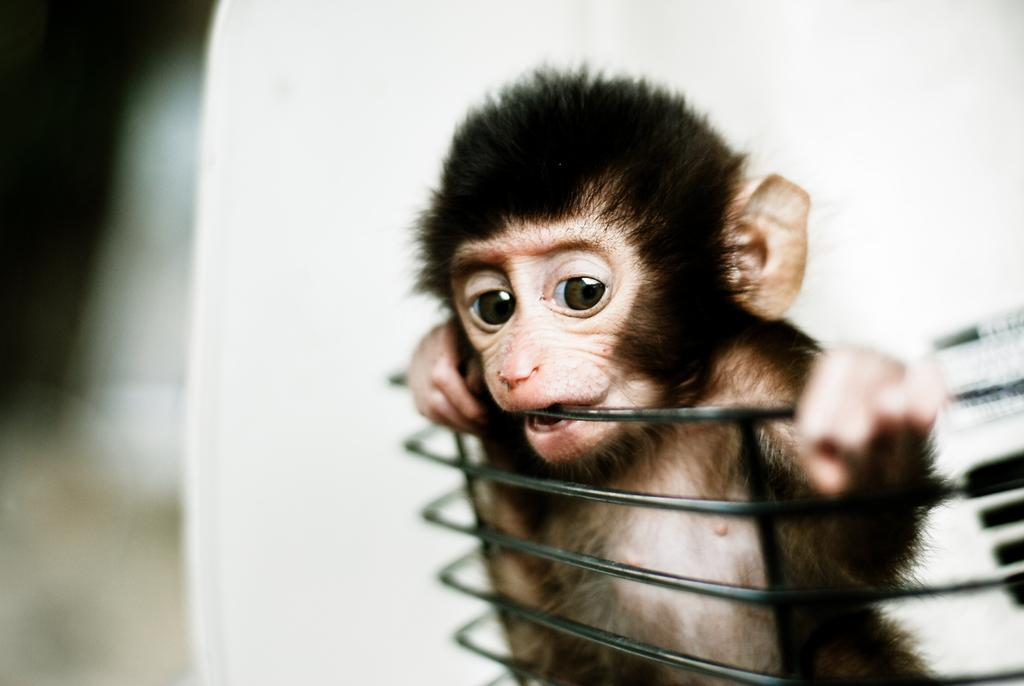What is the main subject of the image? There is a black color monkey in the image. What color is the background of the image? The background of the image is white. How would you describe the overall clarity of the image? The image is slightly blurry in the background. Can you see any caves in the background of the image? There are no caves visible in the image; the background is white and slightly blurry. 